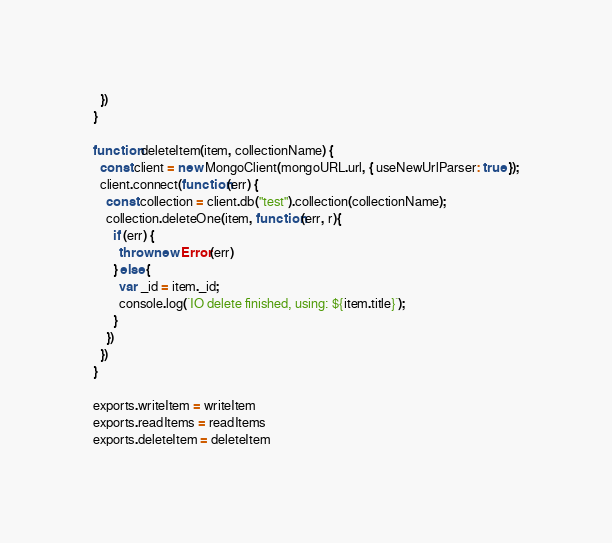Convert code to text. <code><loc_0><loc_0><loc_500><loc_500><_JavaScript_>  })
}

function deleteItem(item, collectionName) {
  const client = new MongoClient(mongoURL.url, { useNewUrlParser: true });
  client.connect(function(err) {
    const collection = client.db("test").collection(collectionName);
    collection.deleteOne(item, function(err, r){
      if (err) {
        throw new Error(err)
      } else {
        var _id = item._id;
        console.log(`IO delete finished, using: ${item.title}`);
      }
    })
  })
}

exports.writeItem = writeItem
exports.readItems = readItems
exports.deleteItem = deleteItem</code> 